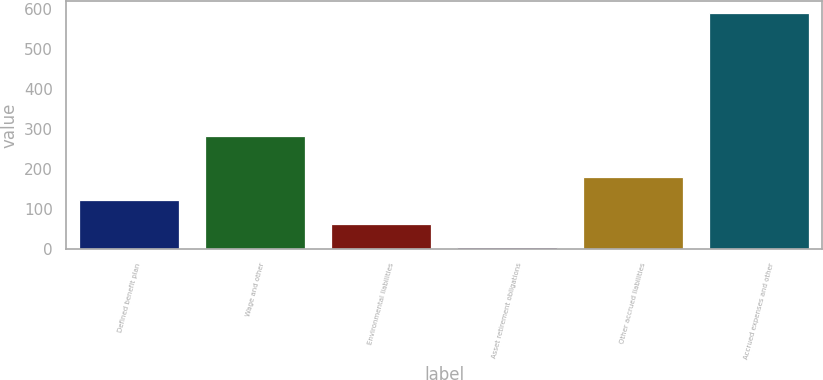<chart> <loc_0><loc_0><loc_500><loc_500><bar_chart><fcel>Defined benefit plan<fcel>Wage and other<fcel>Environmental liabilities<fcel>Asset retirement obligations<fcel>Other accrued liabilities<fcel>Accrued expenses and other<nl><fcel>122<fcel>282<fcel>63.5<fcel>5<fcel>180.5<fcel>590<nl></chart> 